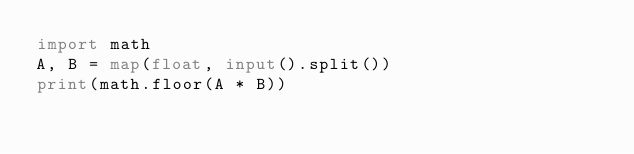<code> <loc_0><loc_0><loc_500><loc_500><_Python_>import math
A, B = map(float, input().split())
print(math.floor(A * B))
</code> 